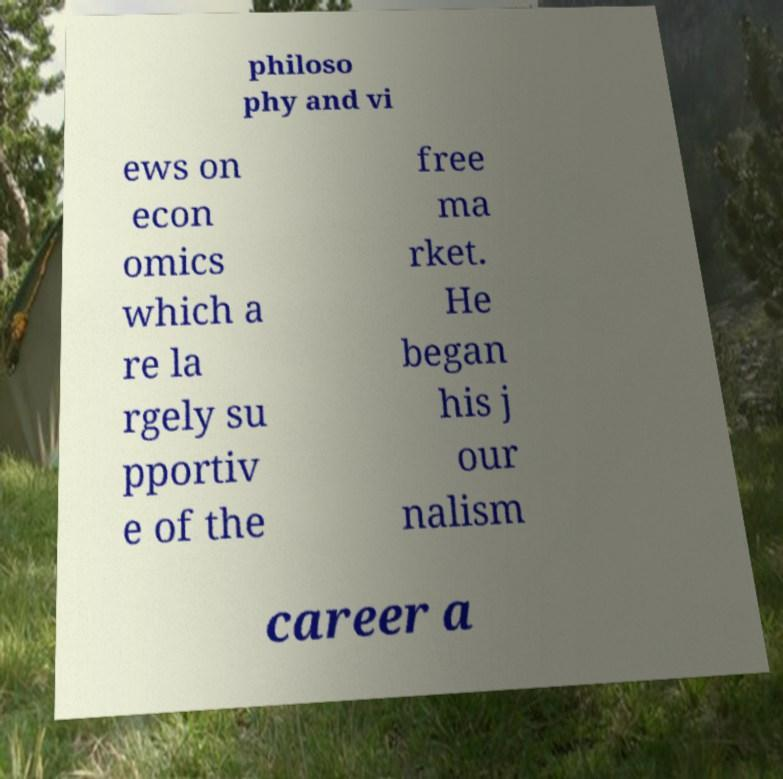Can you accurately transcribe the text from the provided image for me? philoso phy and vi ews on econ omics which a re la rgely su pportiv e of the free ma rket. He began his j our nalism career a 